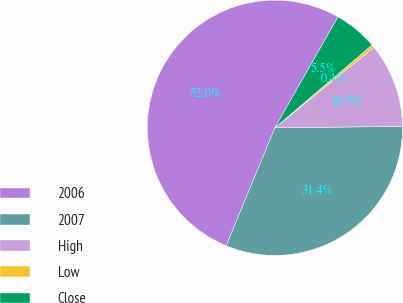<chart> <loc_0><loc_0><loc_500><loc_500><pie_chart><fcel>2006<fcel>2007<fcel>High<fcel>Low<fcel>Close<nl><fcel>51.99%<fcel>31.41%<fcel>10.7%<fcel>0.37%<fcel>5.53%<nl></chart> 